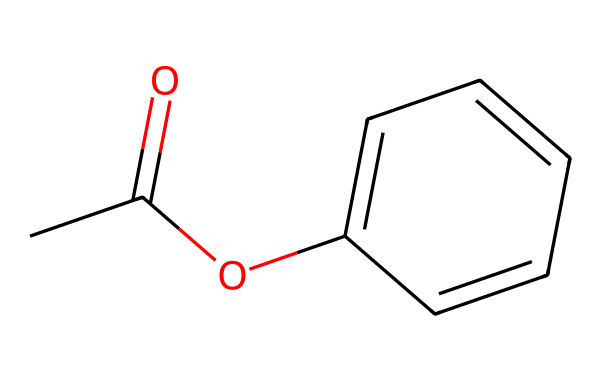What is the functional group present in this compound? The SMILES representation indicates a carbonyl group (C=O) and an ether group (C-O-C). The presence of the carbonyl group suggests an ester functional group is present.
Answer: ester How many carbon atoms are in this chemical? By analyzing the SMILES, we can count the number of carbon atoms present in the overall structure. Counting gives us five carbon atoms in the ring and one attached to the carbonyl, totaling six.
Answer: six What is the degree of unsaturation in this molecule? To determine the degree of unsaturation, we apply the formula: degree of unsaturation = (2C + 2 + N - H - X)/2. Here, C = 6, H = 6, and there are no X or N. Substituting these into the formula gives us a degree of unsaturation of 2, indicating two rings or double bonds.
Answer: two Does this chemical act as a solvent or a non-electrolyte? Non-electrolytes are substances that do not dissociate into ions in solution. Since this chemical has no ionizable groups shown in the structure, it acts more as a non-electrolyte than a solvent.
Answer: non-electrolyte What type of compounds commonly use this structure in varnish formulations? This structure is typical of many synthetic varnishes and coatings due to its ester group, which provides desirable properties like film formation and flexibility. Therefore, this compound is used in synthetic varnishes.
Answer: synthetic varnishes What effect do the aromatic rings in this structure have on its properties? Aromatic rings in a structure often lead to increased stability and resistance to degradation, enhancing the durability of varnishes. The presence of the benzene ring increases hydrophobicity and therefore restricts water permeability.
Answer: increased stability 